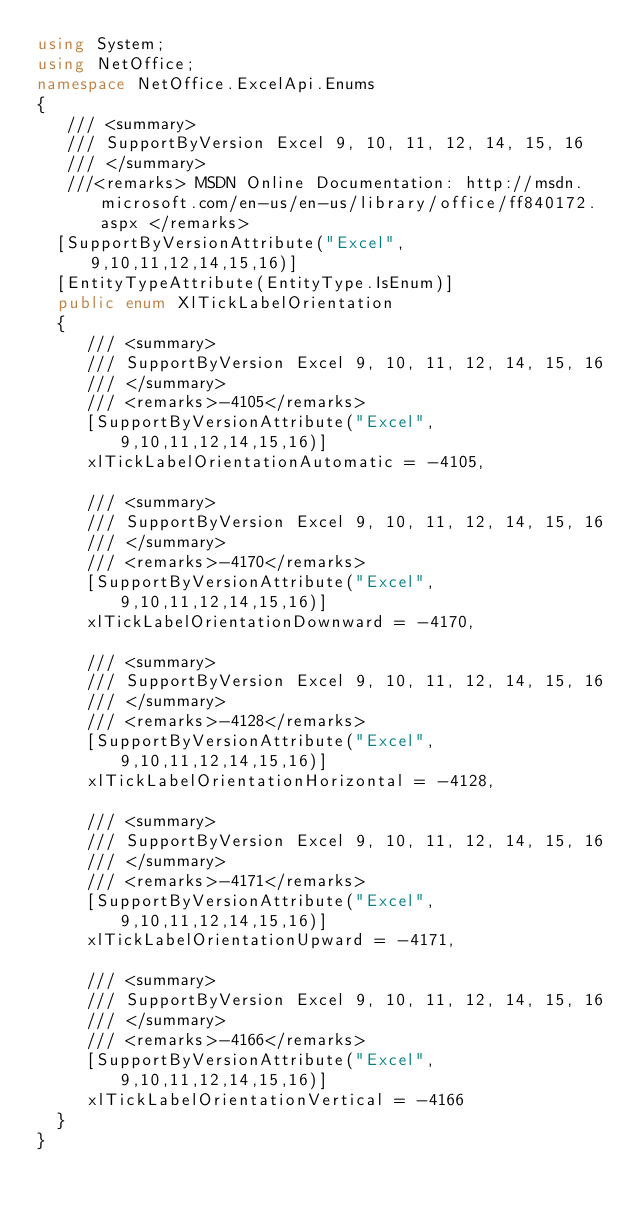<code> <loc_0><loc_0><loc_500><loc_500><_C#_>using System;
using NetOffice;
namespace NetOffice.ExcelApi.Enums
{
	 /// <summary>
	 /// SupportByVersion Excel 9, 10, 11, 12, 14, 15, 16
	 /// </summary>
	 ///<remarks> MSDN Online Documentation: http://msdn.microsoft.com/en-us/en-us/library/office/ff840172.aspx </remarks>
	[SupportByVersionAttribute("Excel", 9,10,11,12,14,15,16)]
	[EntityTypeAttribute(EntityType.IsEnum)]
	public enum XlTickLabelOrientation
	{
		 /// <summary>
		 /// SupportByVersion Excel 9, 10, 11, 12, 14, 15, 16
		 /// </summary>
		 /// <remarks>-4105</remarks>
		 [SupportByVersionAttribute("Excel", 9,10,11,12,14,15,16)]
		 xlTickLabelOrientationAutomatic = -4105,

		 /// <summary>
		 /// SupportByVersion Excel 9, 10, 11, 12, 14, 15, 16
		 /// </summary>
		 /// <remarks>-4170</remarks>
		 [SupportByVersionAttribute("Excel", 9,10,11,12,14,15,16)]
		 xlTickLabelOrientationDownward = -4170,

		 /// <summary>
		 /// SupportByVersion Excel 9, 10, 11, 12, 14, 15, 16
		 /// </summary>
		 /// <remarks>-4128</remarks>
		 [SupportByVersionAttribute("Excel", 9,10,11,12,14,15,16)]
		 xlTickLabelOrientationHorizontal = -4128,

		 /// <summary>
		 /// SupportByVersion Excel 9, 10, 11, 12, 14, 15, 16
		 /// </summary>
		 /// <remarks>-4171</remarks>
		 [SupportByVersionAttribute("Excel", 9,10,11,12,14,15,16)]
		 xlTickLabelOrientationUpward = -4171,

		 /// <summary>
		 /// SupportByVersion Excel 9, 10, 11, 12, 14, 15, 16
		 /// </summary>
		 /// <remarks>-4166</remarks>
		 [SupportByVersionAttribute("Excel", 9,10,11,12,14,15,16)]
		 xlTickLabelOrientationVertical = -4166
	}
}</code> 